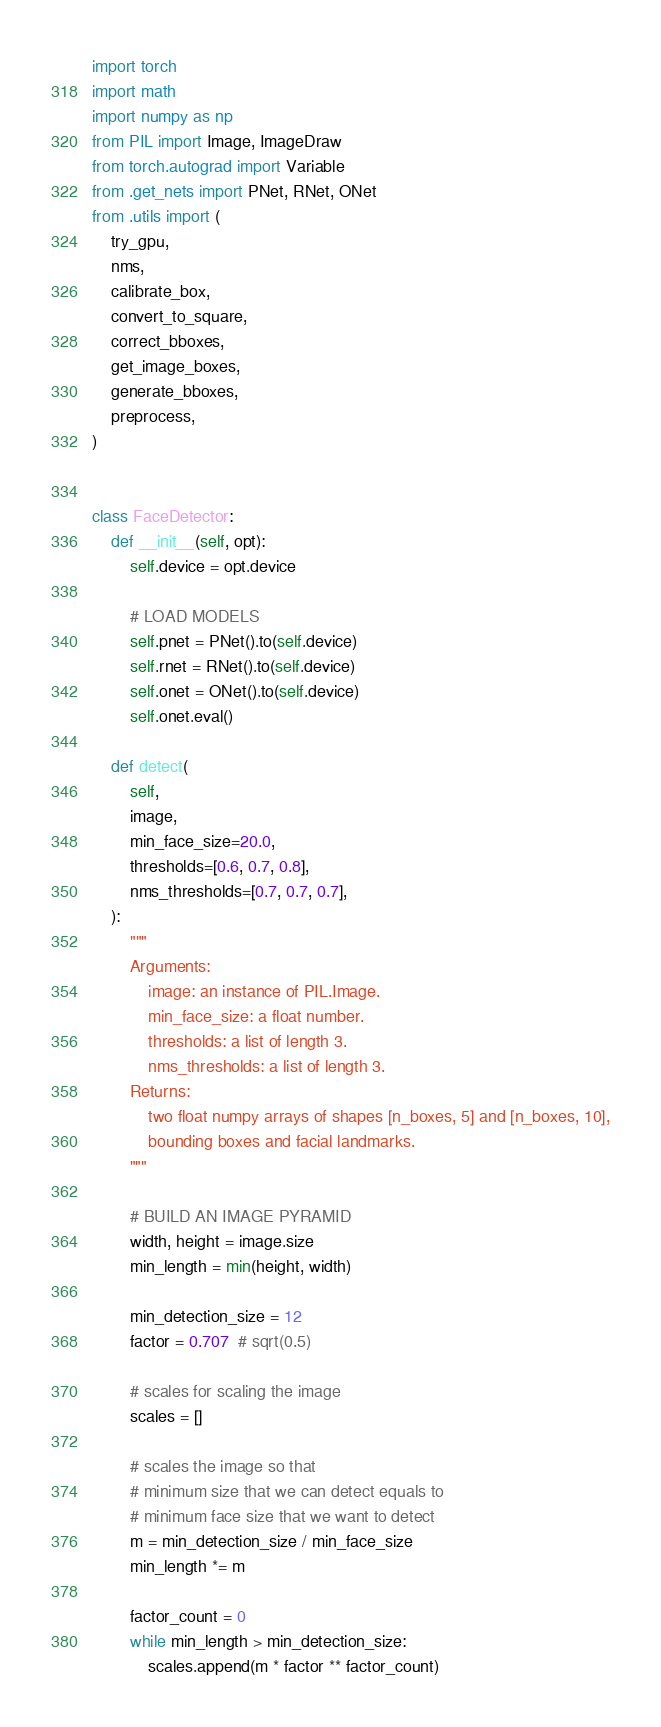Convert code to text. <code><loc_0><loc_0><loc_500><loc_500><_Python_>import torch
import math
import numpy as np
from PIL import Image, ImageDraw
from torch.autograd import Variable
from .get_nets import PNet, RNet, ONet
from .utils import (
    try_gpu,
    nms,
    calibrate_box,
    convert_to_square,
    correct_bboxes,
    get_image_boxes,
    generate_bboxes,
    preprocess,
)


class FaceDetector:
    def __init__(self, opt):
        self.device = opt.device

        # LOAD MODELS
        self.pnet = PNet().to(self.device)
        self.rnet = RNet().to(self.device)
        self.onet = ONet().to(self.device)
        self.onet.eval()

    def detect(
        self,
        image,
        min_face_size=20.0,
        thresholds=[0.6, 0.7, 0.8],
        nms_thresholds=[0.7, 0.7, 0.7],
    ):
        """
        Arguments:
            image: an instance of PIL.Image.
            min_face_size: a float number.
            thresholds: a list of length 3.
            nms_thresholds: a list of length 3.
        Returns:
            two float numpy arrays of shapes [n_boxes, 5] and [n_boxes, 10],
            bounding boxes and facial landmarks.
        """

        # BUILD AN IMAGE PYRAMID
        width, height = image.size
        min_length = min(height, width)

        min_detection_size = 12
        factor = 0.707  # sqrt(0.5)

        # scales for scaling the image
        scales = []

        # scales the image so that
        # minimum size that we can detect equals to
        # minimum face size that we want to detect
        m = min_detection_size / min_face_size
        min_length *= m

        factor_count = 0
        while min_length > min_detection_size:
            scales.append(m * factor ** factor_count)</code> 